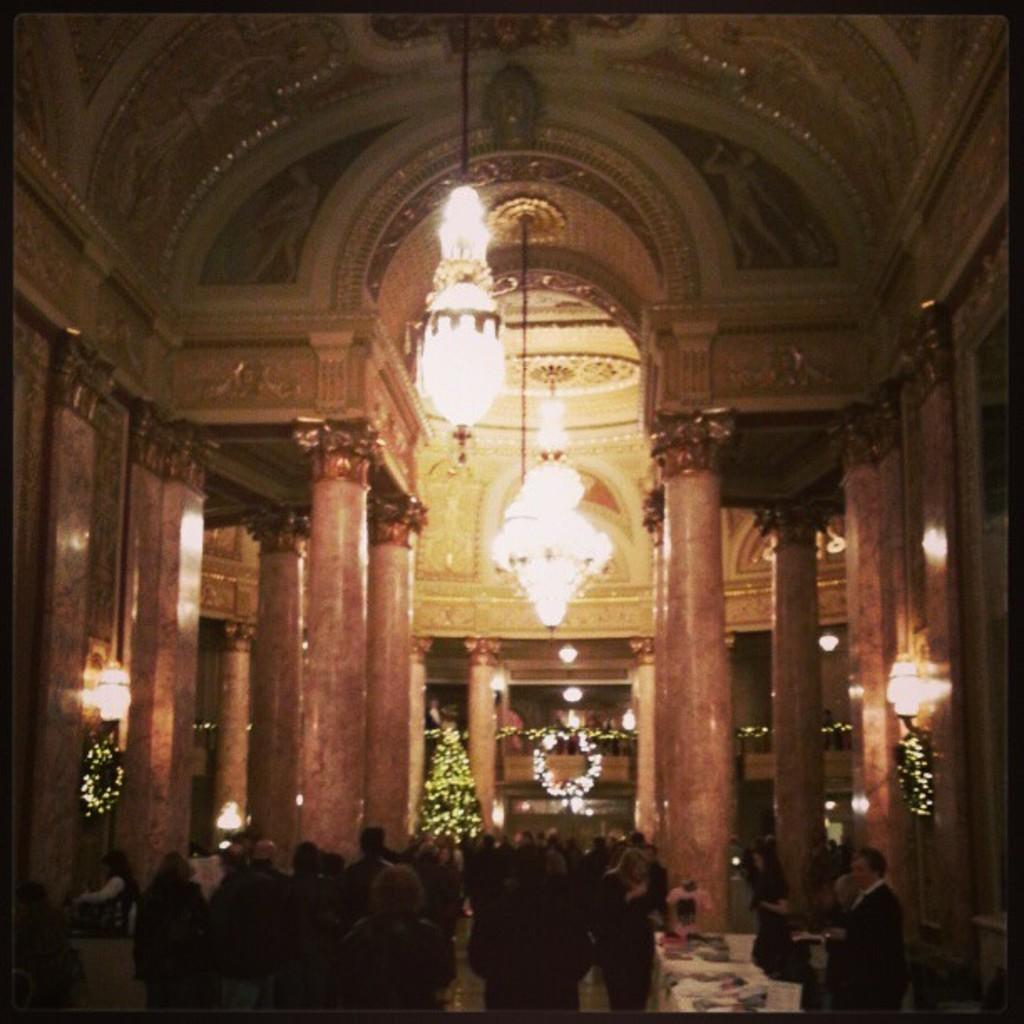What is the main setting of the image? The main setting of the image is a palace. What is happening inside the palace? There is a crowd inside the palace. Are there any specific decorations or features in the palace? Yes, there is a Christmas tree and the palace is beautifully decorated with lights. What news is being reported by the person standing next to the police officer in the image? There is no person standing next to a police officer in the image, nor is there any news being reported. 